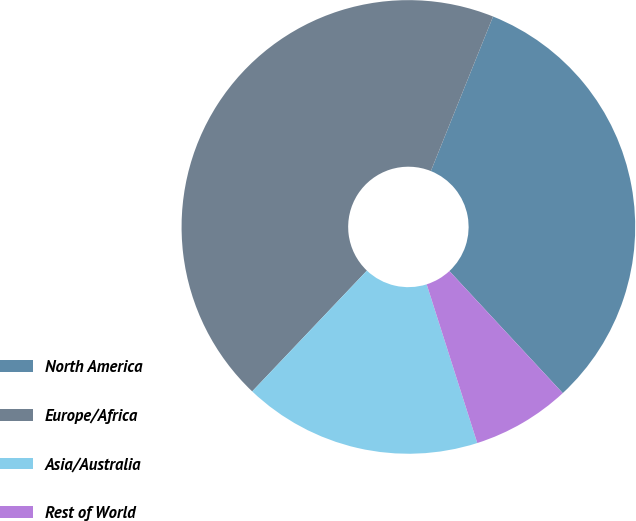Convert chart. <chart><loc_0><loc_0><loc_500><loc_500><pie_chart><fcel>North America<fcel>Europe/Africa<fcel>Asia/Australia<fcel>Rest of World<nl><fcel>32.0%<fcel>44.0%<fcel>17.0%<fcel>7.0%<nl></chart> 